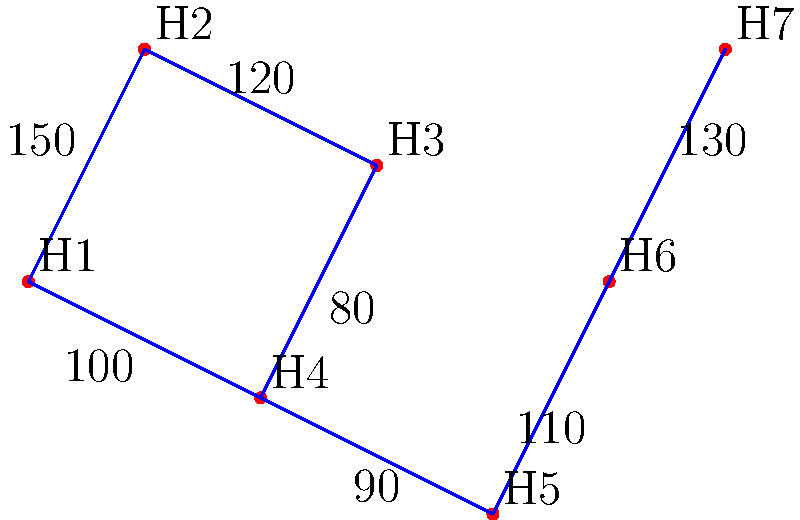As a golf course designer inspired by Sheila Vaughan's innovative layouts, you're tasked with connecting 7 golf holes (H1 to H7) using the minimum amount of cart path. The diagram shows the distances (in yards) between holes. What is the total length of cart path needed to connect all holes using a minimum spanning tree? To solve this problem, we'll use Kruskal's algorithm to find the minimum spanning tree:

1. Sort edges by weight (ascending):
   80 (H3-H4), 90 (H4-H5), 100 (H1-H4), 110 (H5-H6), 120 (H2-H3), 130 (H6-H7), 150 (H1-H2)

2. Add edges to the tree, avoiding cycles:
   - Add 80 (H3-H4)
   - Add 90 (H4-H5)
   - Add 100 (H1-H4)
   - Add 110 (H5-H6)
   - Add 120 (H2-H3)
   - Add 130 (H6-H7)

3. The minimum spanning tree is complete with 6 edges (n-1, where n is the number of vertices).

4. Sum the weights of the selected edges:
   80 + 90 + 100 + 110 + 120 + 130 = 630

Therefore, the total length of cart path needed is 630 yards.
Answer: 630 yards 